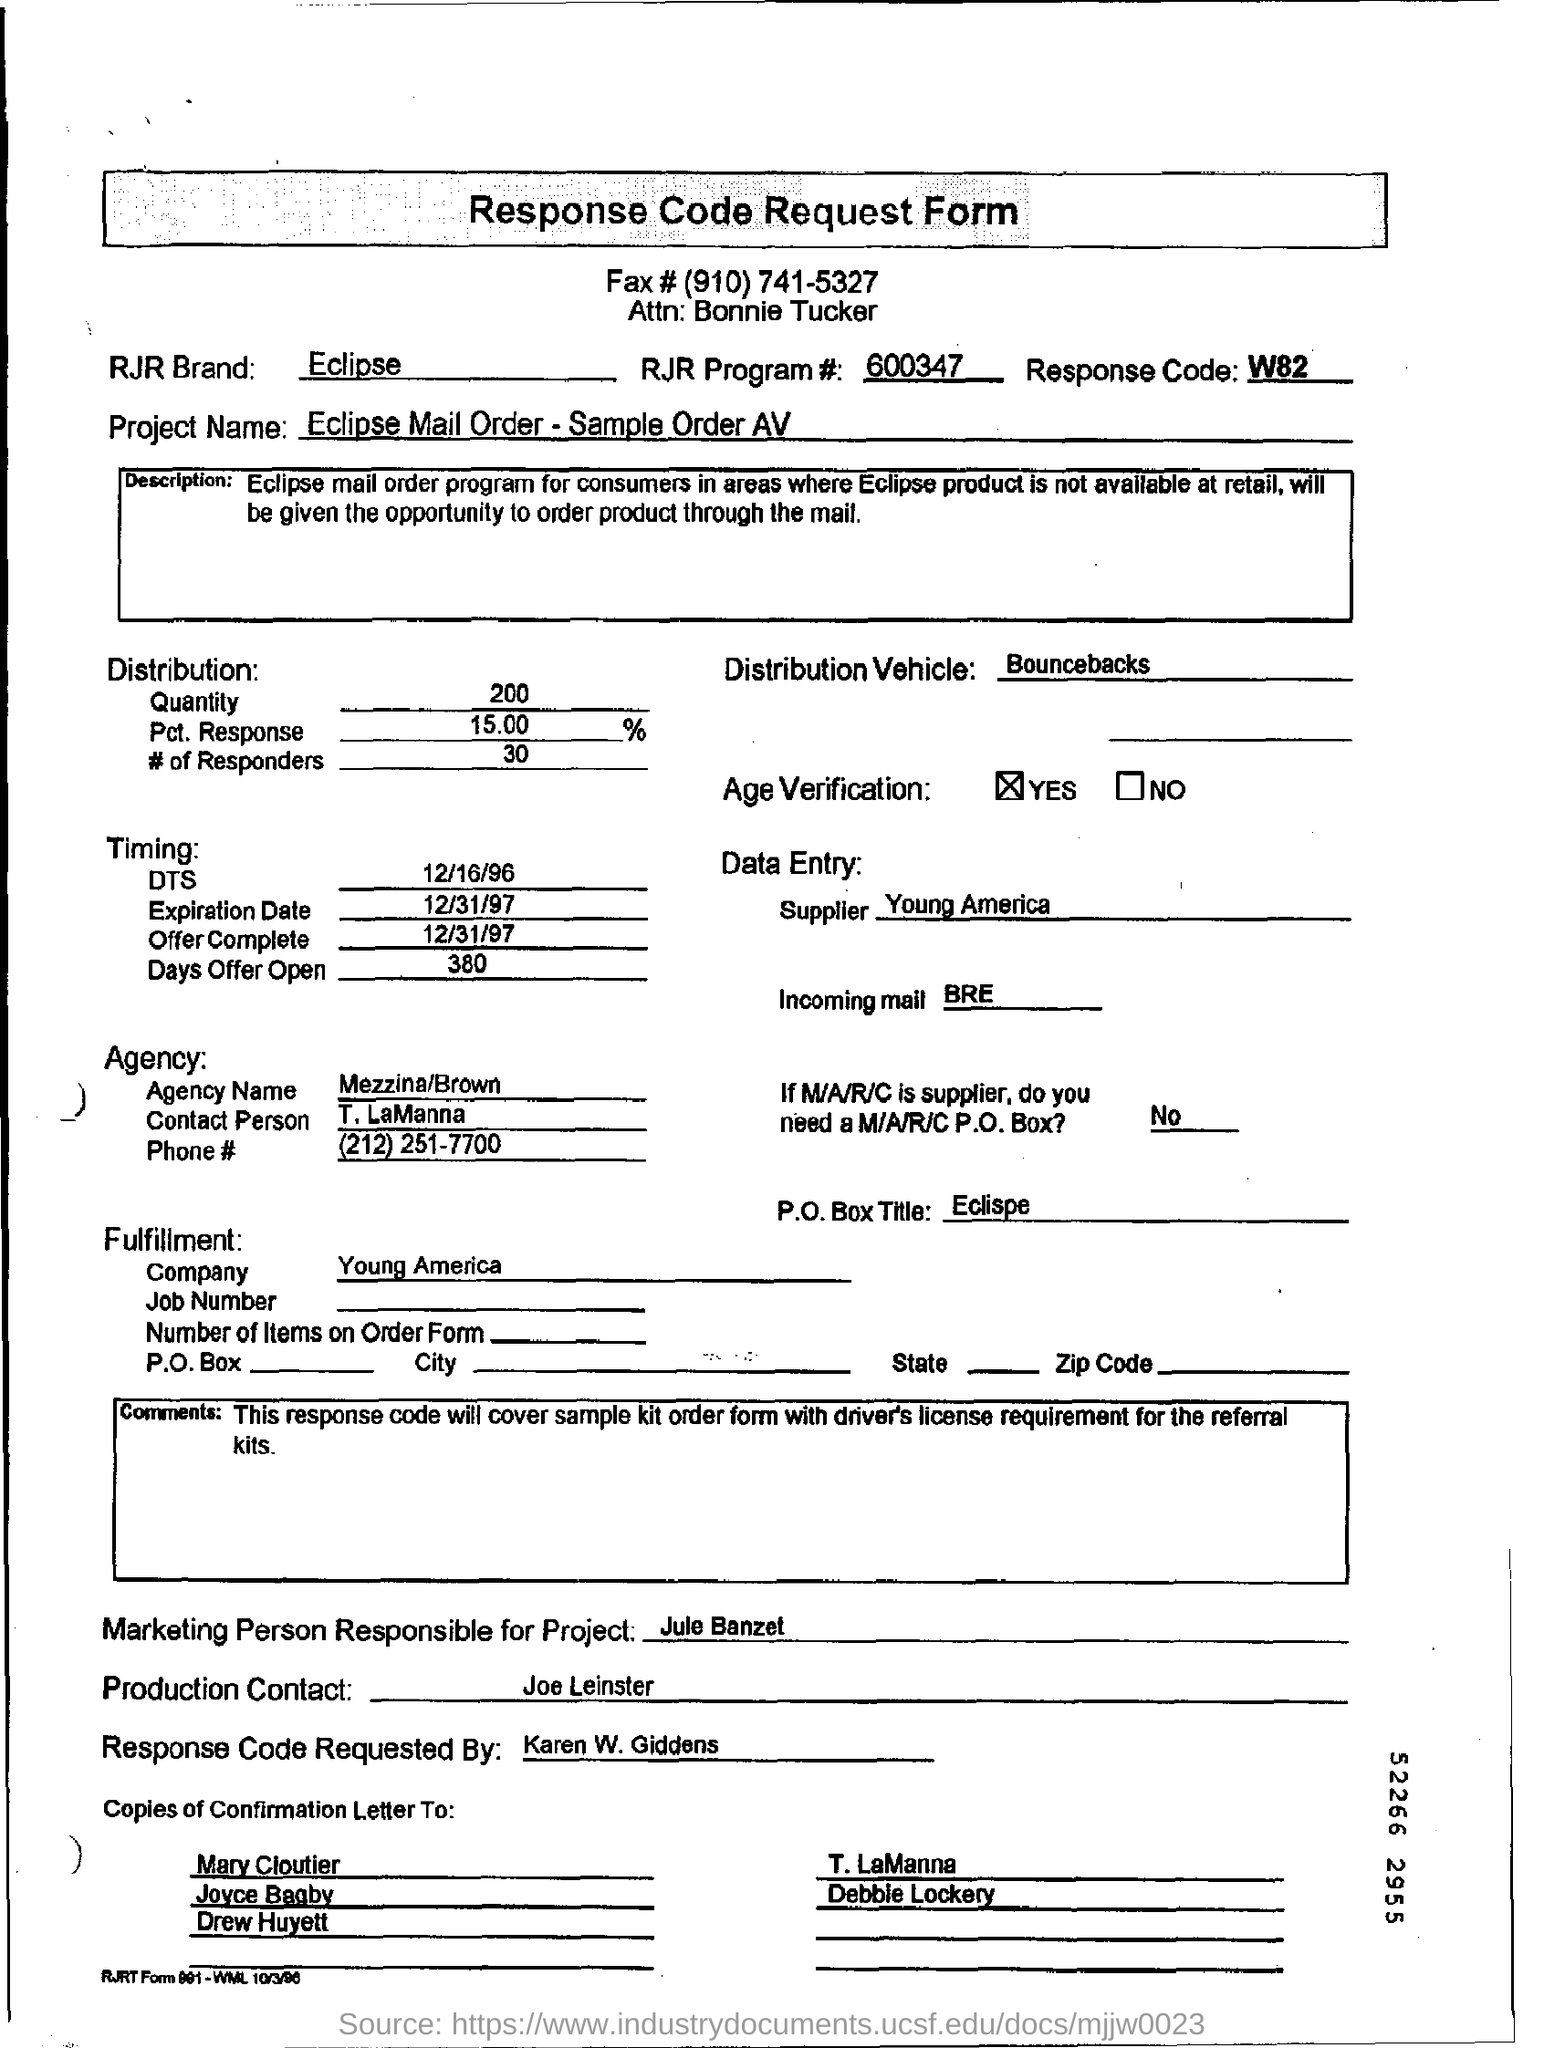Point out several critical features in this image. The first name in the "Copies of Confirmation Letter To" column is Mary Cloutier. The RJR Brand name is Eclipse. The supplier mentioned in the data entry is Young America. 